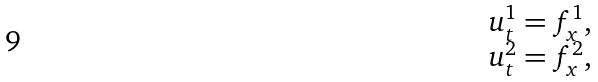Convert formula to latex. <formula><loc_0><loc_0><loc_500><loc_500>\begin{array} { c } u _ { t } ^ { 1 } = f ^ { 1 } _ { x } , \\ u _ { t } ^ { 2 } = f ^ { 2 } _ { x } , \end{array}</formula> 